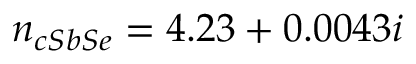Convert formula to latex. <formula><loc_0><loc_0><loc_500><loc_500>n _ { c S b S e } = 4 . 2 3 + 0 . 0 0 4 3 i</formula> 